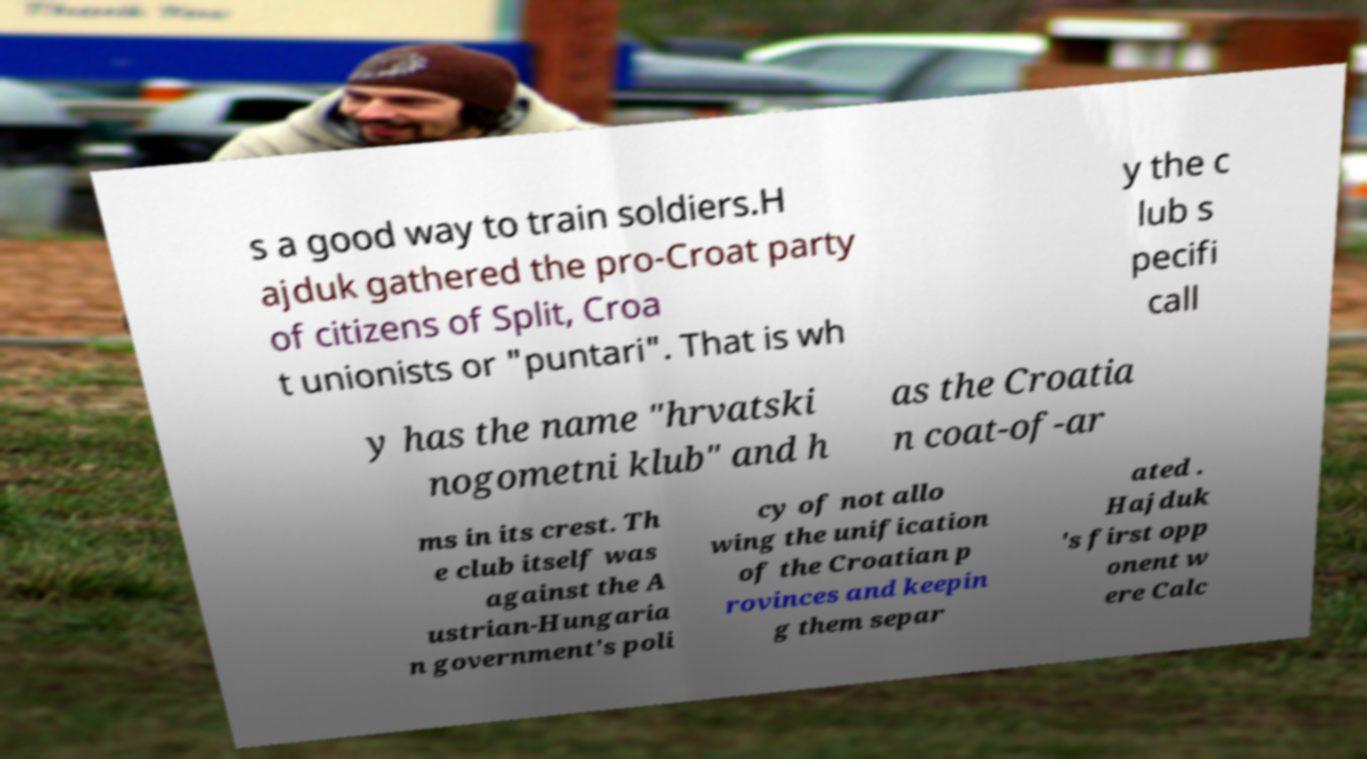Please read and relay the text visible in this image. What does it say? s a good way to train soldiers.H ajduk gathered the pro-Croat party of citizens of Split, Croa t unionists or "puntari". That is wh y the c lub s pecifi call y has the name "hrvatski nogometni klub" and h as the Croatia n coat-of-ar ms in its crest. Th e club itself was against the A ustrian-Hungaria n government's poli cy of not allo wing the unification of the Croatian p rovinces and keepin g them separ ated . Hajduk 's first opp onent w ere Calc 